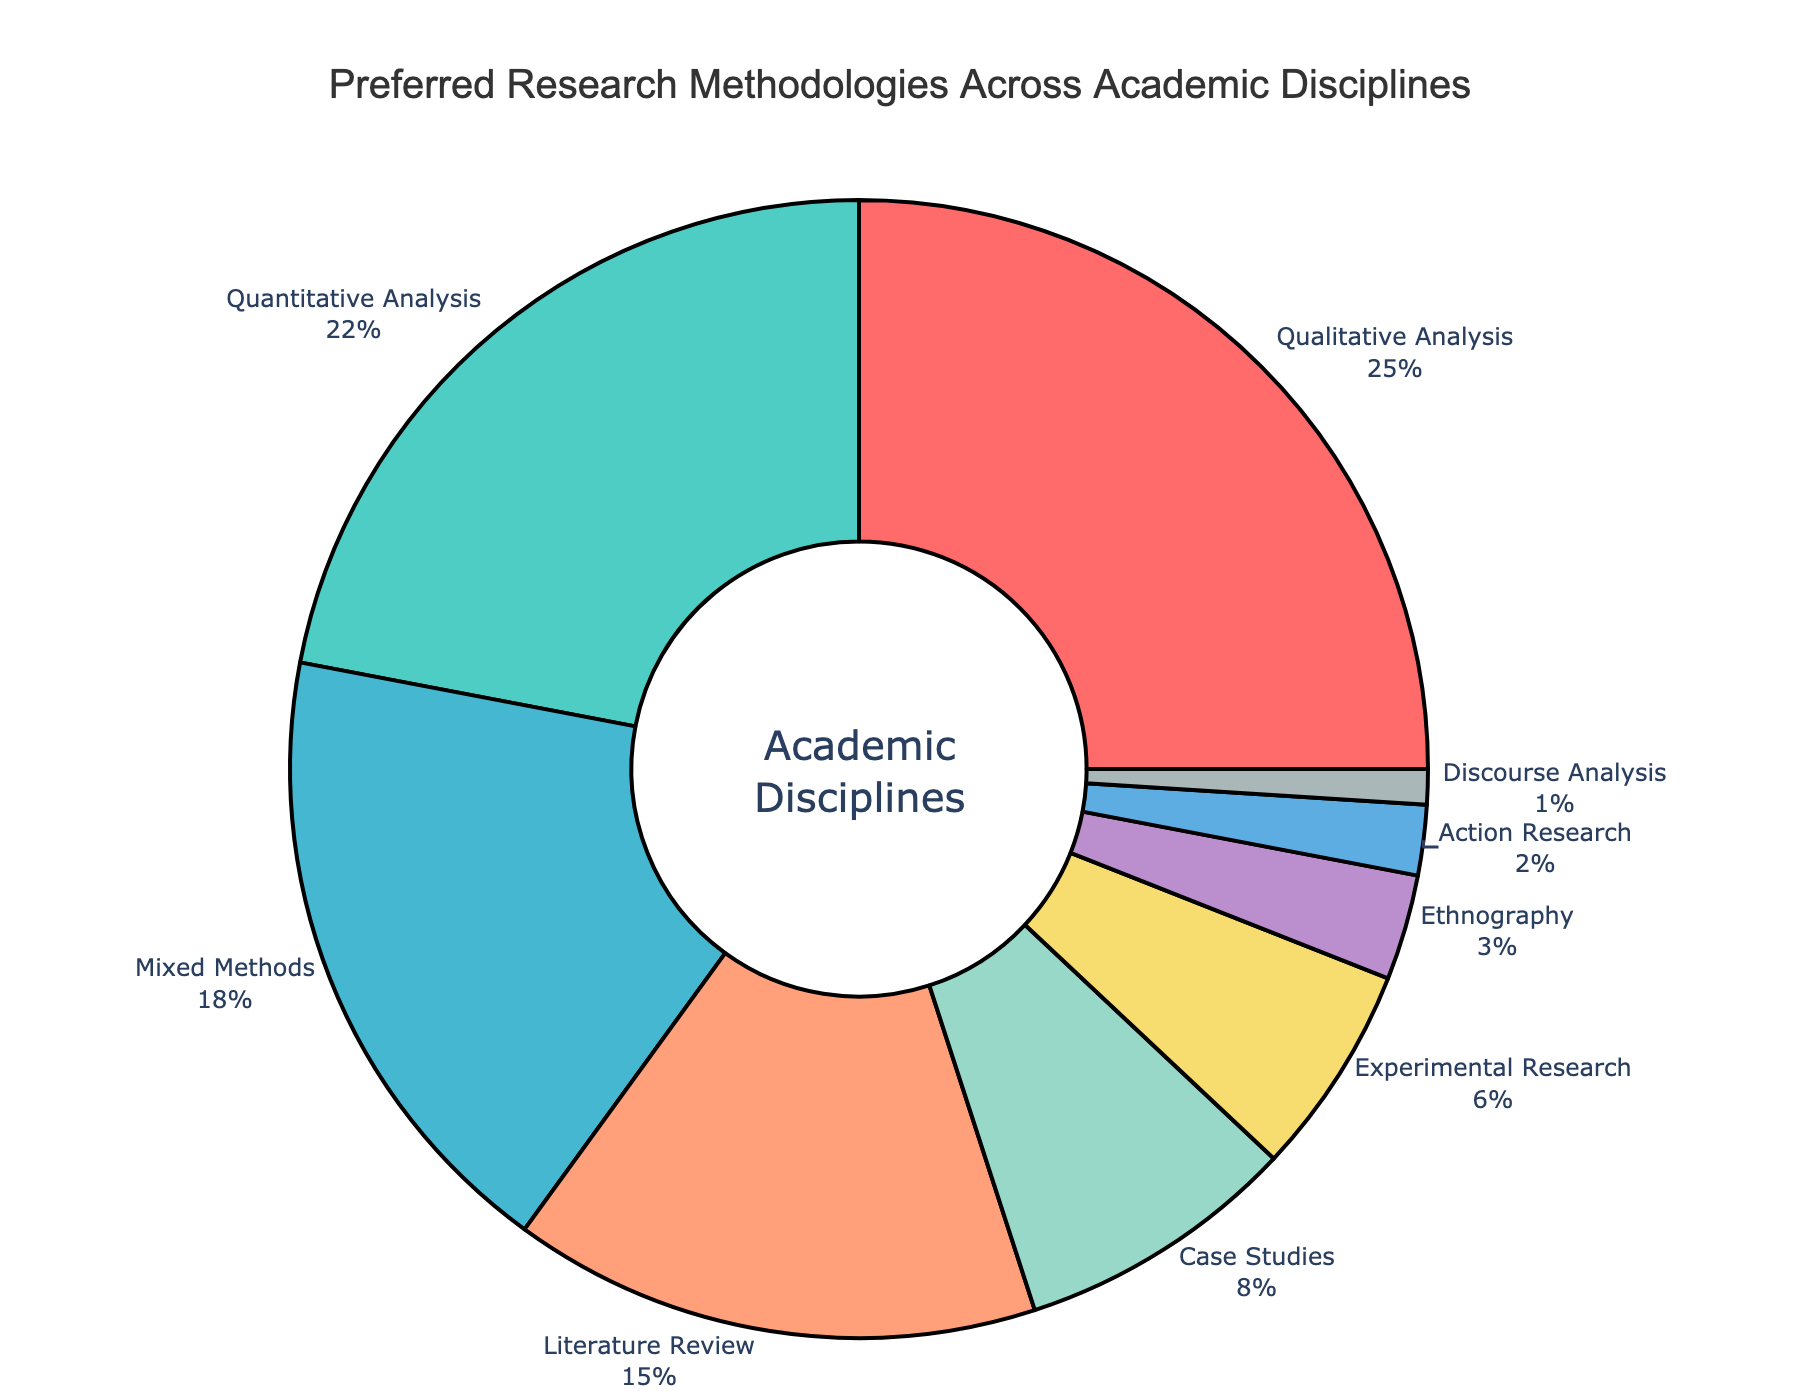What research methodology has the highest preference among the disciplines? The segment labeled 'Qualitative Analysis' has the highest percentage at 25%, indicating the highest preference.
Answer: Qualitative Analysis Which research methodology is preferred more: Case Studies or Experimental Research? The 'Case Studies' segment represents 8%, while the 'Experimental Research' segment represents 6%. Thus, Case Studies are preferred more.
Answer: Case Studies What is the combined percentage of Qualitative Analysis, Quantitative Analysis, and Mixed Methods? Adding the percentages for 'Qualitative Analysis' (25%), 'Quantitative Analysis' (22%), and 'Mixed Methods' (18%) gives a total of 25 + 22 + 18 = 65%.
Answer: 65% Is the percentage of Ethnography greater than the sum of Action Research and Discourse Analysis? The 'Ethnography' segment is 3%. The sum of 'Action Research' (2%) and 'Discourse Analysis' (1%) is 2 + 1 = 3%. Both are equal.
Answer: No What proportion of the chart is occupied by methodologies other than Qualitative Analysis and Quantitative Analysis? The percentages for 'Qualitative Analysis' and 'Quantitative Analysis' together are 25% + 22% = 47%. The rest of the chart is 100% - 47% = 53%.
Answer: 53% Identify the smallest research methodology preference noted in the chart. The smallest segment is labeled 'Discourse Analysis' with 1%.
Answer: Discourse Analysis What is the difference in percentage between Literature Review and Mixed Methods? 'Literature Review' stands at 15%, and 'Mixed Methods' are at 18%. The difference is 18 - 15 = 3%.
Answer: 3% How much more preferred is the methodology represented by the blue segment compared to the methodology represented by the green segment? The blue segment ('Quantitative Analysis') represents 22%, and the green segment ('Case Studies') represents 8%. The difference is 22 - 8 = 14%.
Answer: 14% If you combine the total percentages of Experimental Research, Ethnography, Action Research, and Discourse Analysis, does it surpass Mixed Methods? The combined total of 'Experimental Research' (6%), 'Ethnography' (3%), 'Action Research' (2%), and 'Discourse Analysis' (1%) is 6 + 3 + 2 + 1 = 12%. This does not surpass 'Mixed Methods' at 18%.
Answer: No 